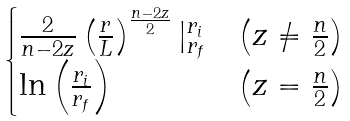Convert formula to latex. <formula><loc_0><loc_0><loc_500><loc_500>\begin{cases} \frac { 2 } { n - 2 z } \left ( \frac { r } { L } \right ) ^ { \frac { n - 2 z } { 2 } } | _ { r _ { f } } ^ { r _ { i } } & \left ( z \neq \frac { n } { 2 } \right ) \\ \ln \left ( \frac { r _ { i } } { r _ { f } } \right ) & \left ( z = \frac { n } { 2 } \right ) \end{cases}</formula> 